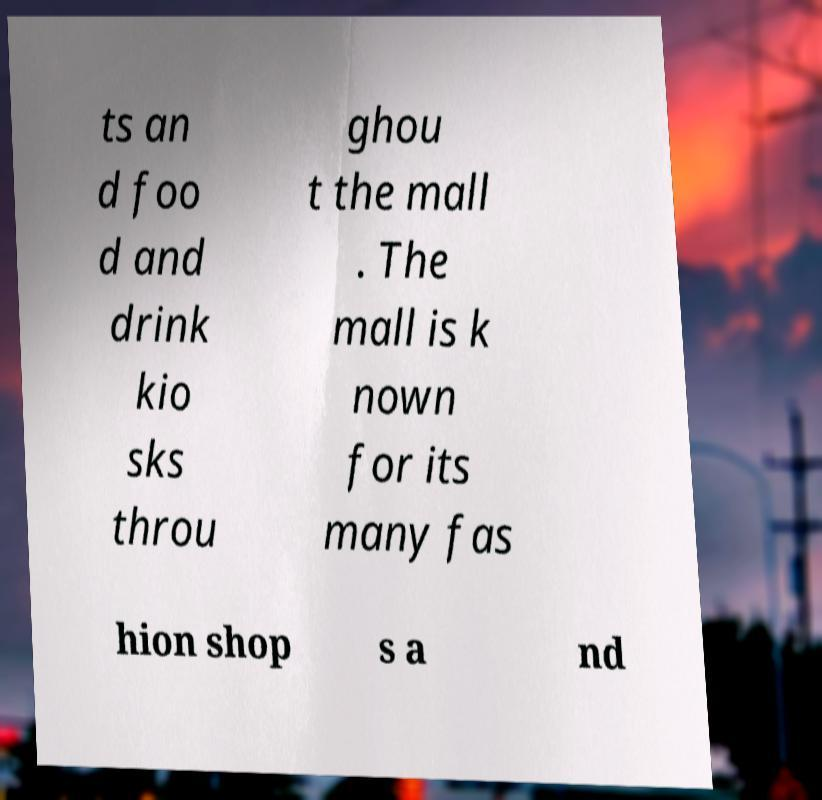Please read and relay the text visible in this image. What does it say? ts an d foo d and drink kio sks throu ghou t the mall . The mall is k nown for its many fas hion shop s a nd 